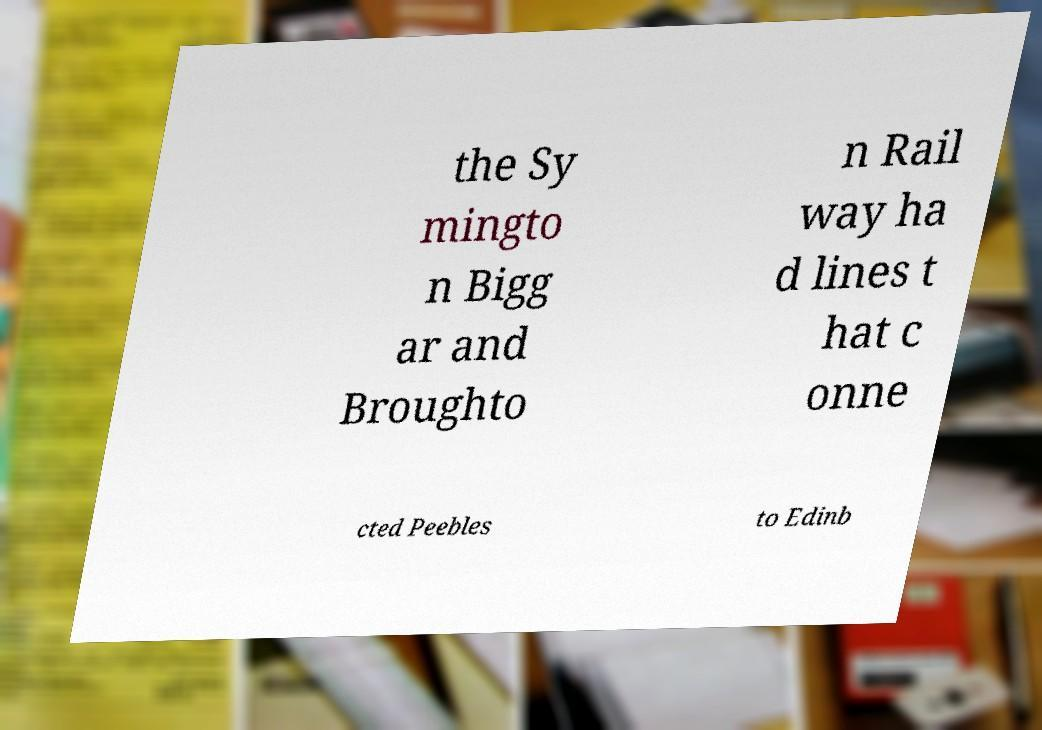I need the written content from this picture converted into text. Can you do that? the Sy mingto n Bigg ar and Broughto n Rail way ha d lines t hat c onne cted Peebles to Edinb 